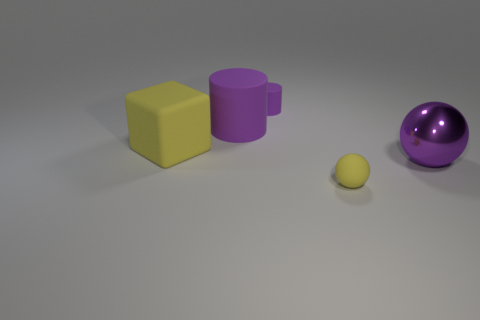Add 2 tiny brown rubber balls. How many objects exist? 7 Subtract all cubes. How many objects are left? 4 Subtract all purple metal cylinders. Subtract all rubber cylinders. How many objects are left? 3 Add 1 cylinders. How many cylinders are left? 3 Add 5 small purple balls. How many small purple balls exist? 5 Subtract 0 cyan cylinders. How many objects are left? 5 